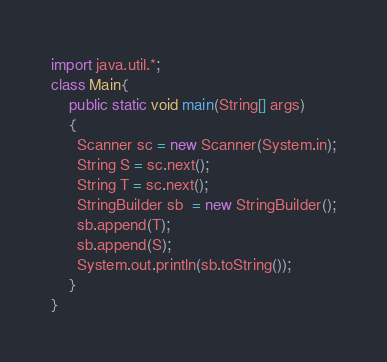Convert code to text. <code><loc_0><loc_0><loc_500><loc_500><_Java_>import java.util.*;
class Main{
	public static void main(String[] args)
    {
      Scanner sc = new Scanner(System.in);
      String S = sc.next();
      String T = sc.next();
      StringBuilder sb  = new StringBuilder();
      sb.append(T);
      sb.append(S);
      System.out.println(sb.toString());
    }
}
</code> 